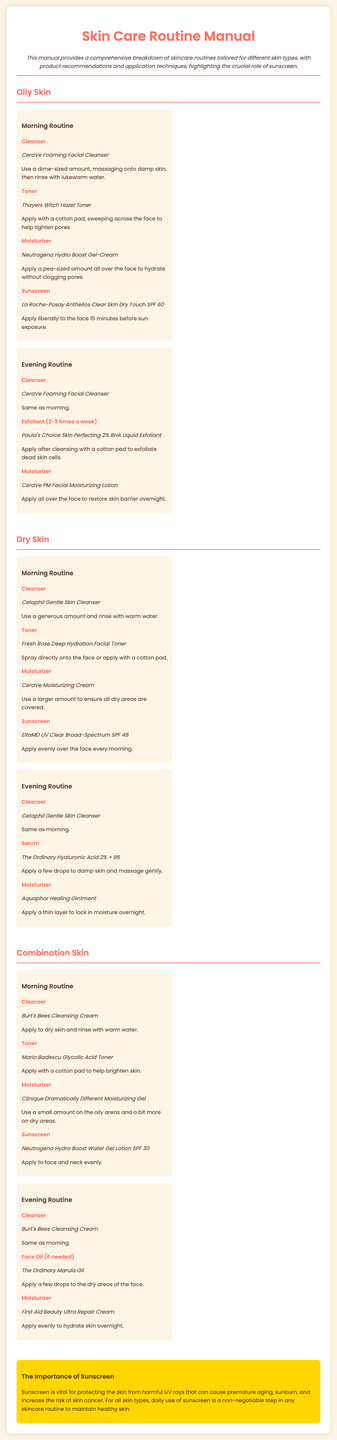What is the cleanser recommended for oily skin? The document provides a specific product recommendation for oily skin under the cleanser section, which is CeraVe Foaming Facial Cleanser.
Answer: CeraVe Foaming Facial Cleanser How often should the exfoliant be used for oily skin? The manual specifies using the exfoliant 2-3 times a week for the oily skin routine.
Answer: 2-3 times a week What moisturizer is recommended for dry skin? The manual lists a specific product for dry skin under the moisturizer section, which is CeraVe Moisturizing Cream.
Answer: CeraVe Moisturizing Cream What type of sunscreen is recommended for combination skin? The document details a specific product for combination skin under the sunscreen section, which is Neutrogena Hydro Boost Water Gel Lotion SPF 30.
Answer: Neutrogena Hydro Boost Water Gel Lotion SPF 30 Which skin type is associated with the product Paula's Choice Skin Perfecting 2% BHA Liquid Exfoliant? The manual categorizes this exfoliant under the routine for oily skin.
Answer: Oily skin What is the main reason sunscreen is important according to the manual? The document explains that sunscreen protects the skin from harmful UV rays that can cause issues like premature aging.
Answer: Protects from harmful UV rays How should the toner be applied for oily skin? It describes applying the toner with a cotton pad, sweeping across the face to help tighten pores.
Answer: With a cotton pad What is the evening moisturizer recommended for dry skin? The evening routine for dry skin includes the recommended product, Aquaphor Healing Ointment, under the moisturizer step.
Answer: Aquaphor Healing Ointment 